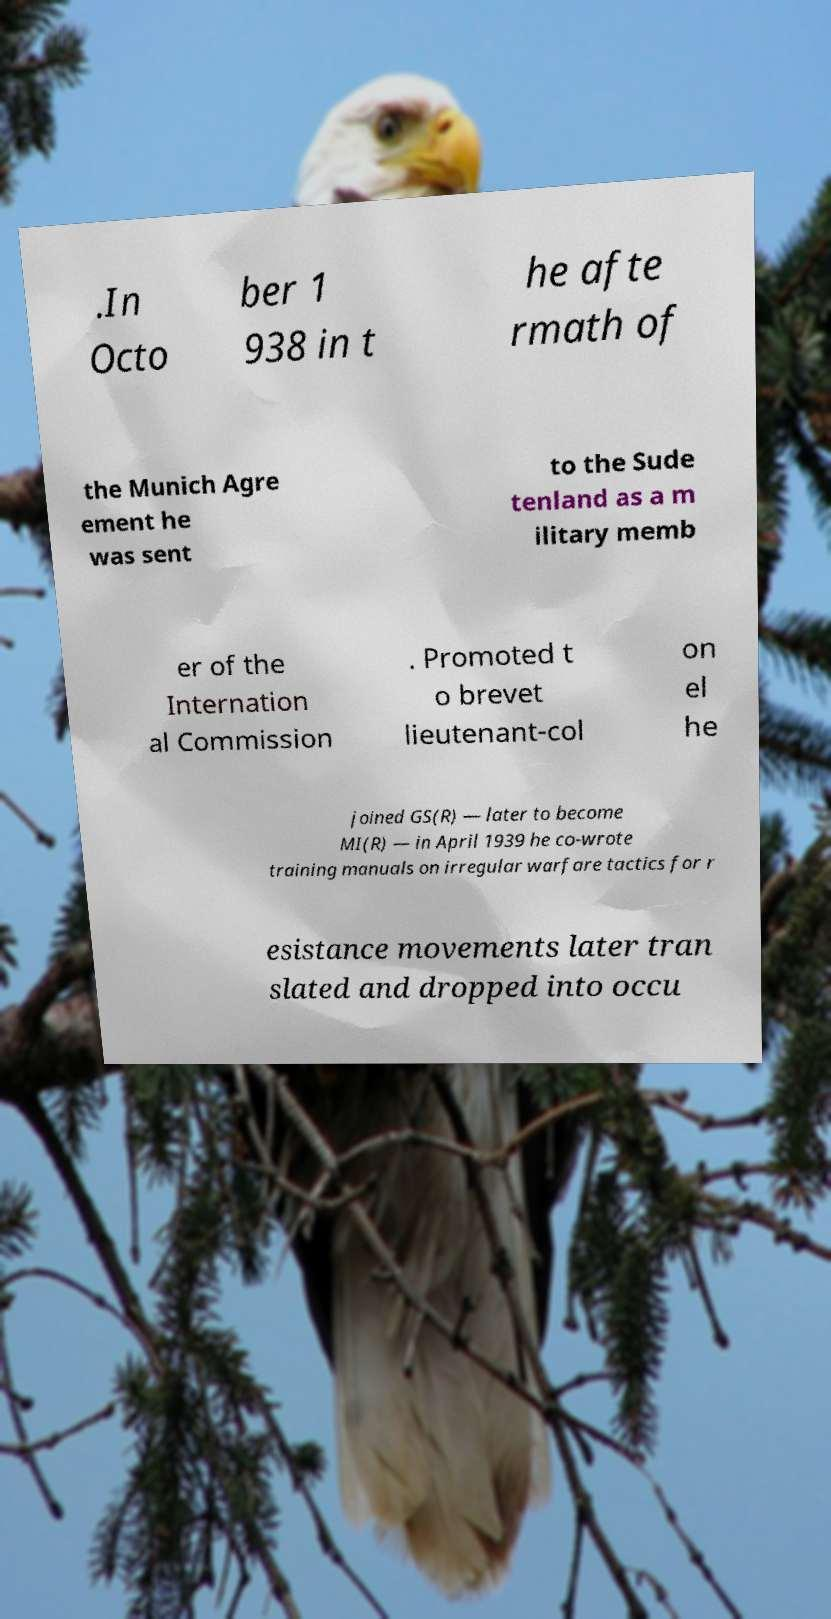Can you read and provide the text displayed in the image?This photo seems to have some interesting text. Can you extract and type it out for me? .In Octo ber 1 938 in t he afte rmath of the Munich Agre ement he was sent to the Sude tenland as a m ilitary memb er of the Internation al Commission . Promoted t o brevet lieutenant-col on el he joined GS(R) — later to become MI(R) — in April 1939 he co-wrote training manuals on irregular warfare tactics for r esistance movements later tran slated and dropped into occu 